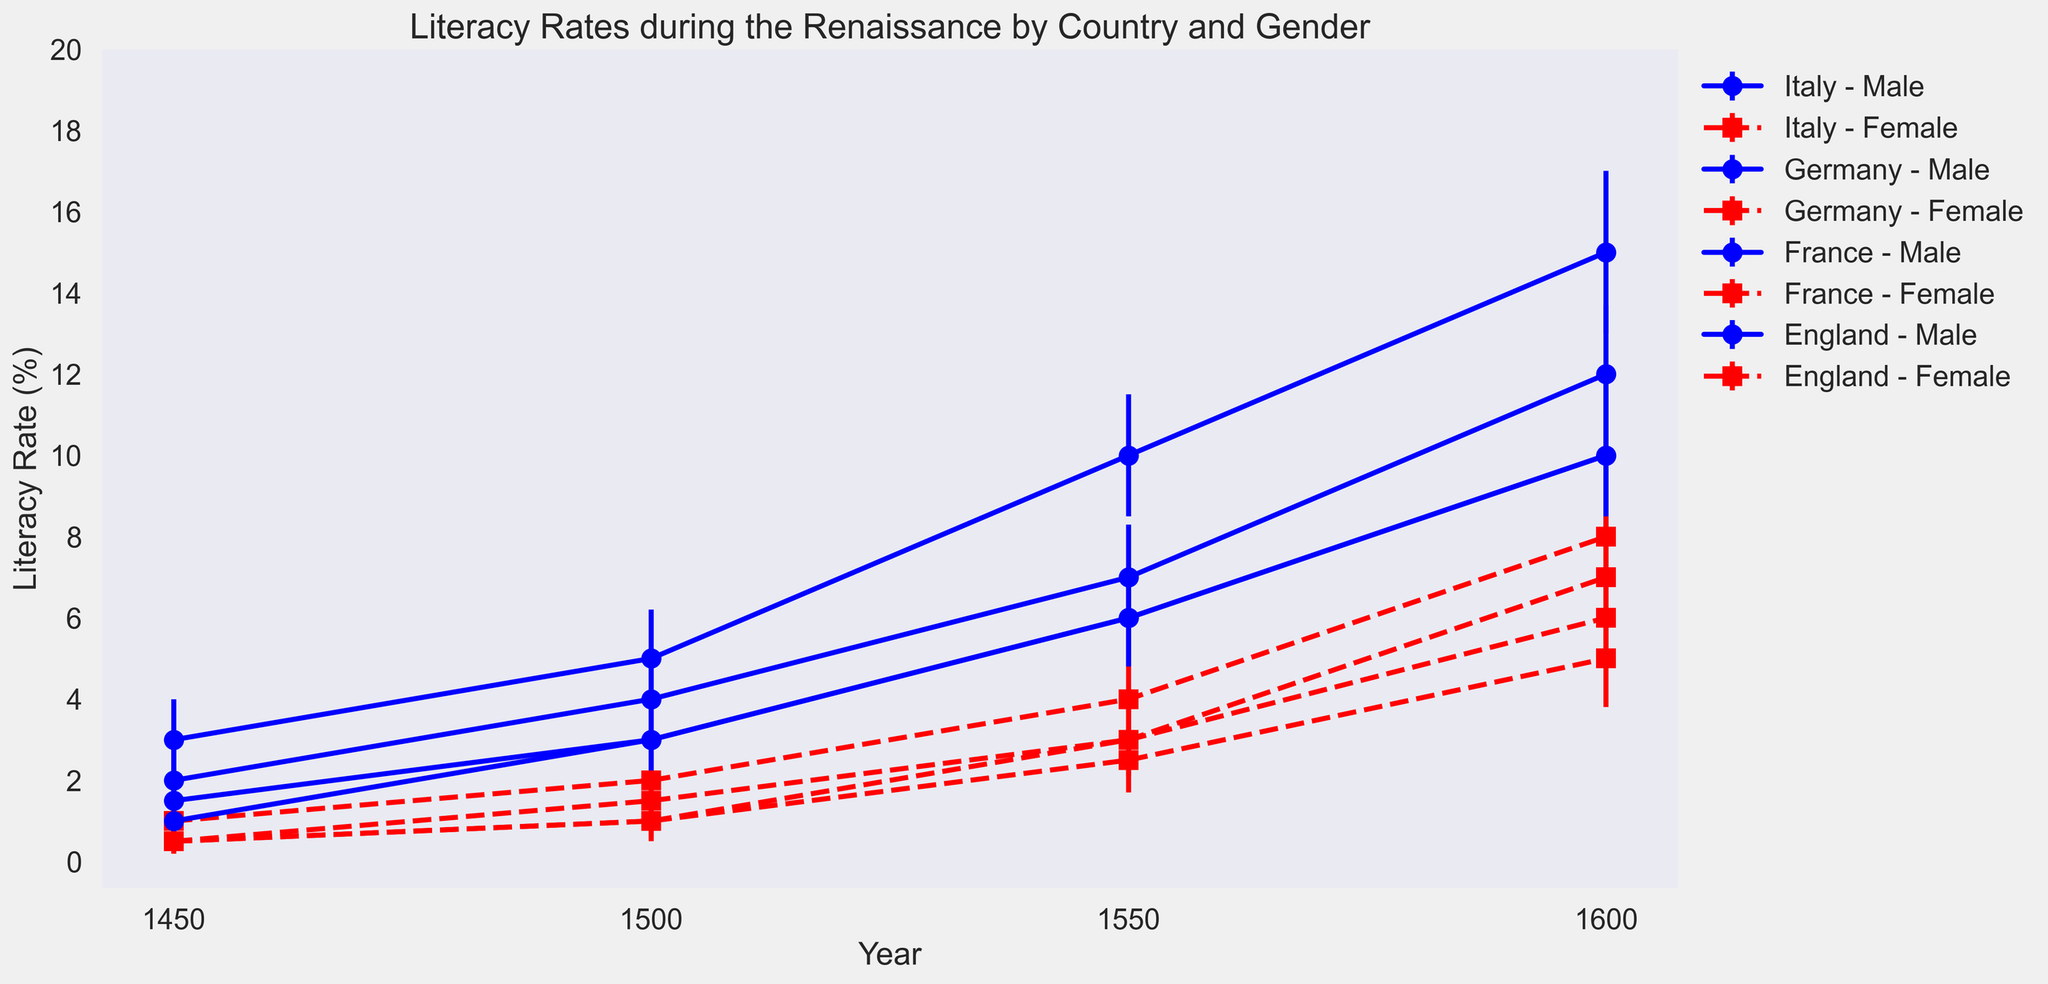What is the difference in the male literacy rate between Italy and Germany in 1600? The male literacy rate for Italy in 1600 is 15%, while for Germany it is 12%. The difference is calculated as 15% - 12% = 3%.
Answer: 3% Which country shows the smallest difference between male and female literacy rates in 1450? From the figure, Italy has a male literacy rate of 3% and a female literacy rate of 1% in 1450, which is a difference of 2%. Germany has 2% (male) and 0.5% (female), a difference of 1.5%. France has 1.5% (male) and 0.5% (female), a difference of 1%. England has 1% (male) and 0.5% (female), a difference of 0.5%. Therefore, England shows the smallest difference.
Answer: England Which gender had a higher increase in literacy rates in France from 1450 to 1600? The male literacy rate in France increased from 1.5% in 1450 to 10% in 1600, which is an increase of 8.5%. The female literacy rate increased from 0.5% in 1450 to 6% in 1600, an increase of 5.5%. Hence, males had a higher increase.
Answer: Males Between Germany and England in 1550, which country had a higher female literacy rate and by how much? Germany had a female literacy rate of 2.5% in 1550, while England had 3%. The difference is 3% - 2.5% = 0.5%. Therefore, England had a higher female literacy rate by 0.5%.
Answer: England by 0.5% In which year did Italy see the highest increase in female literacy rates compared to the previous recorded year, and what was the increase? In Italy, the female literacy rates are 1% (1450), 2% (1500), 4% (1550), and 8% (1600). The differences between consecutive years are 1% (1500-1450), 2% (1550-1500), and 4% (1600-1550). The highest increase is 4% between 1550 and 1600.
Answer: 1600, 4% By how much more did England's female literacy rate increase compared to Germany's female literacy rate from 1450 to 1600? England's female literacy rate increased from 0.5% in 1450 to 7% in 1600, an increase of 6.5%. Germany's female literacy rate increased from 0.5% in 1450 to 5% in 1600, an increase of 4.5%. The difference is 6.5% - 4.5% = 2%.
Answer: 2% Which country shows the most significant gap between male and female literacy rates in 1600? In 1600, the differences between male and female literacy rates are: Italy (15% - 8% = 7%), Germany (12% - 5% = 7%), France (10% - 6% = 4%), and England (10% - 7% = 3%). Italy and Germany both show the most significant gaps of 7%.
Answer: Italy and Germany What trend can be seen in the female literacy rates in all countries over the years? Observing the figure, the female literacy rates in all countries show an upward trend from 1450 to 1600, indicating gradual increases over time.
Answer: Upward trend Does any country exhibit a decline in male literacy rates at any point in the recorded years? By examining the figure, it is noticeable that in all countries, male literacy rates either rise or remain constant; no country shows a decline at any point between 1450 and 1600.
Answer: No 